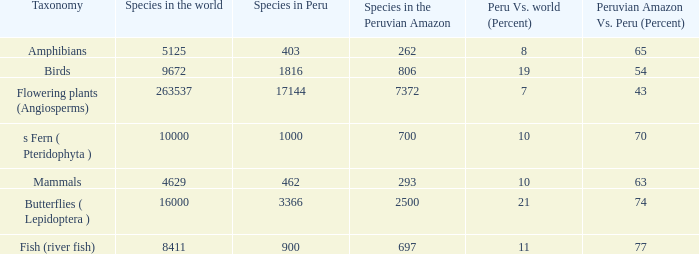How many species of ferns (pteridophyta) are there at a minimum in the peruvian amazon? 700.0. 